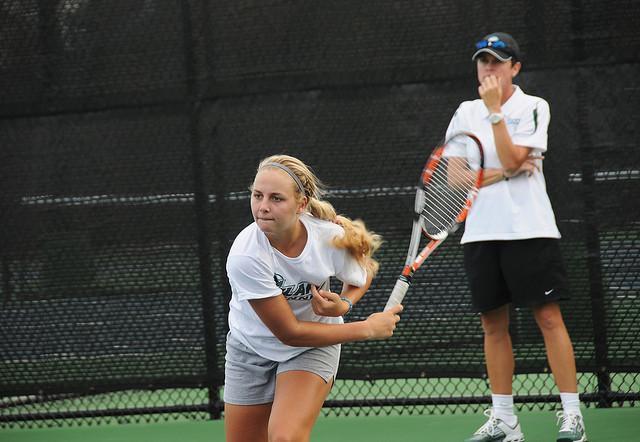How many people are wearing long pants?
Give a very brief answer. 0. How many people are visible?
Give a very brief answer. 2. 